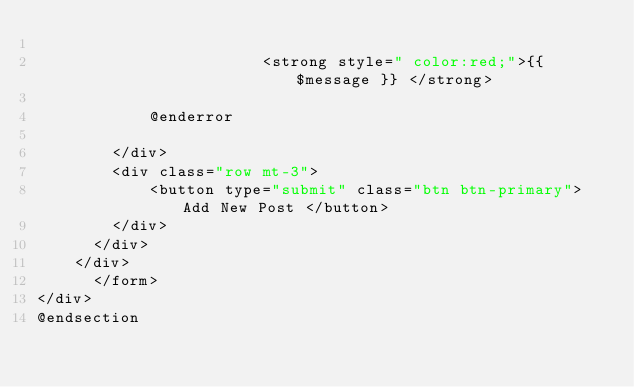<code> <loc_0><loc_0><loc_500><loc_500><_PHP_>                   
                        <strong style=" color:red;">{{ $message }} </strong>
                   
            @enderror  
                
        </div>
        <div class="row mt-3">
            <button type="submit" class="btn btn-primary">Add New Post </button>
        </div>
      </div>
    </div>
      </form>
</div>
@endsection
</code> 